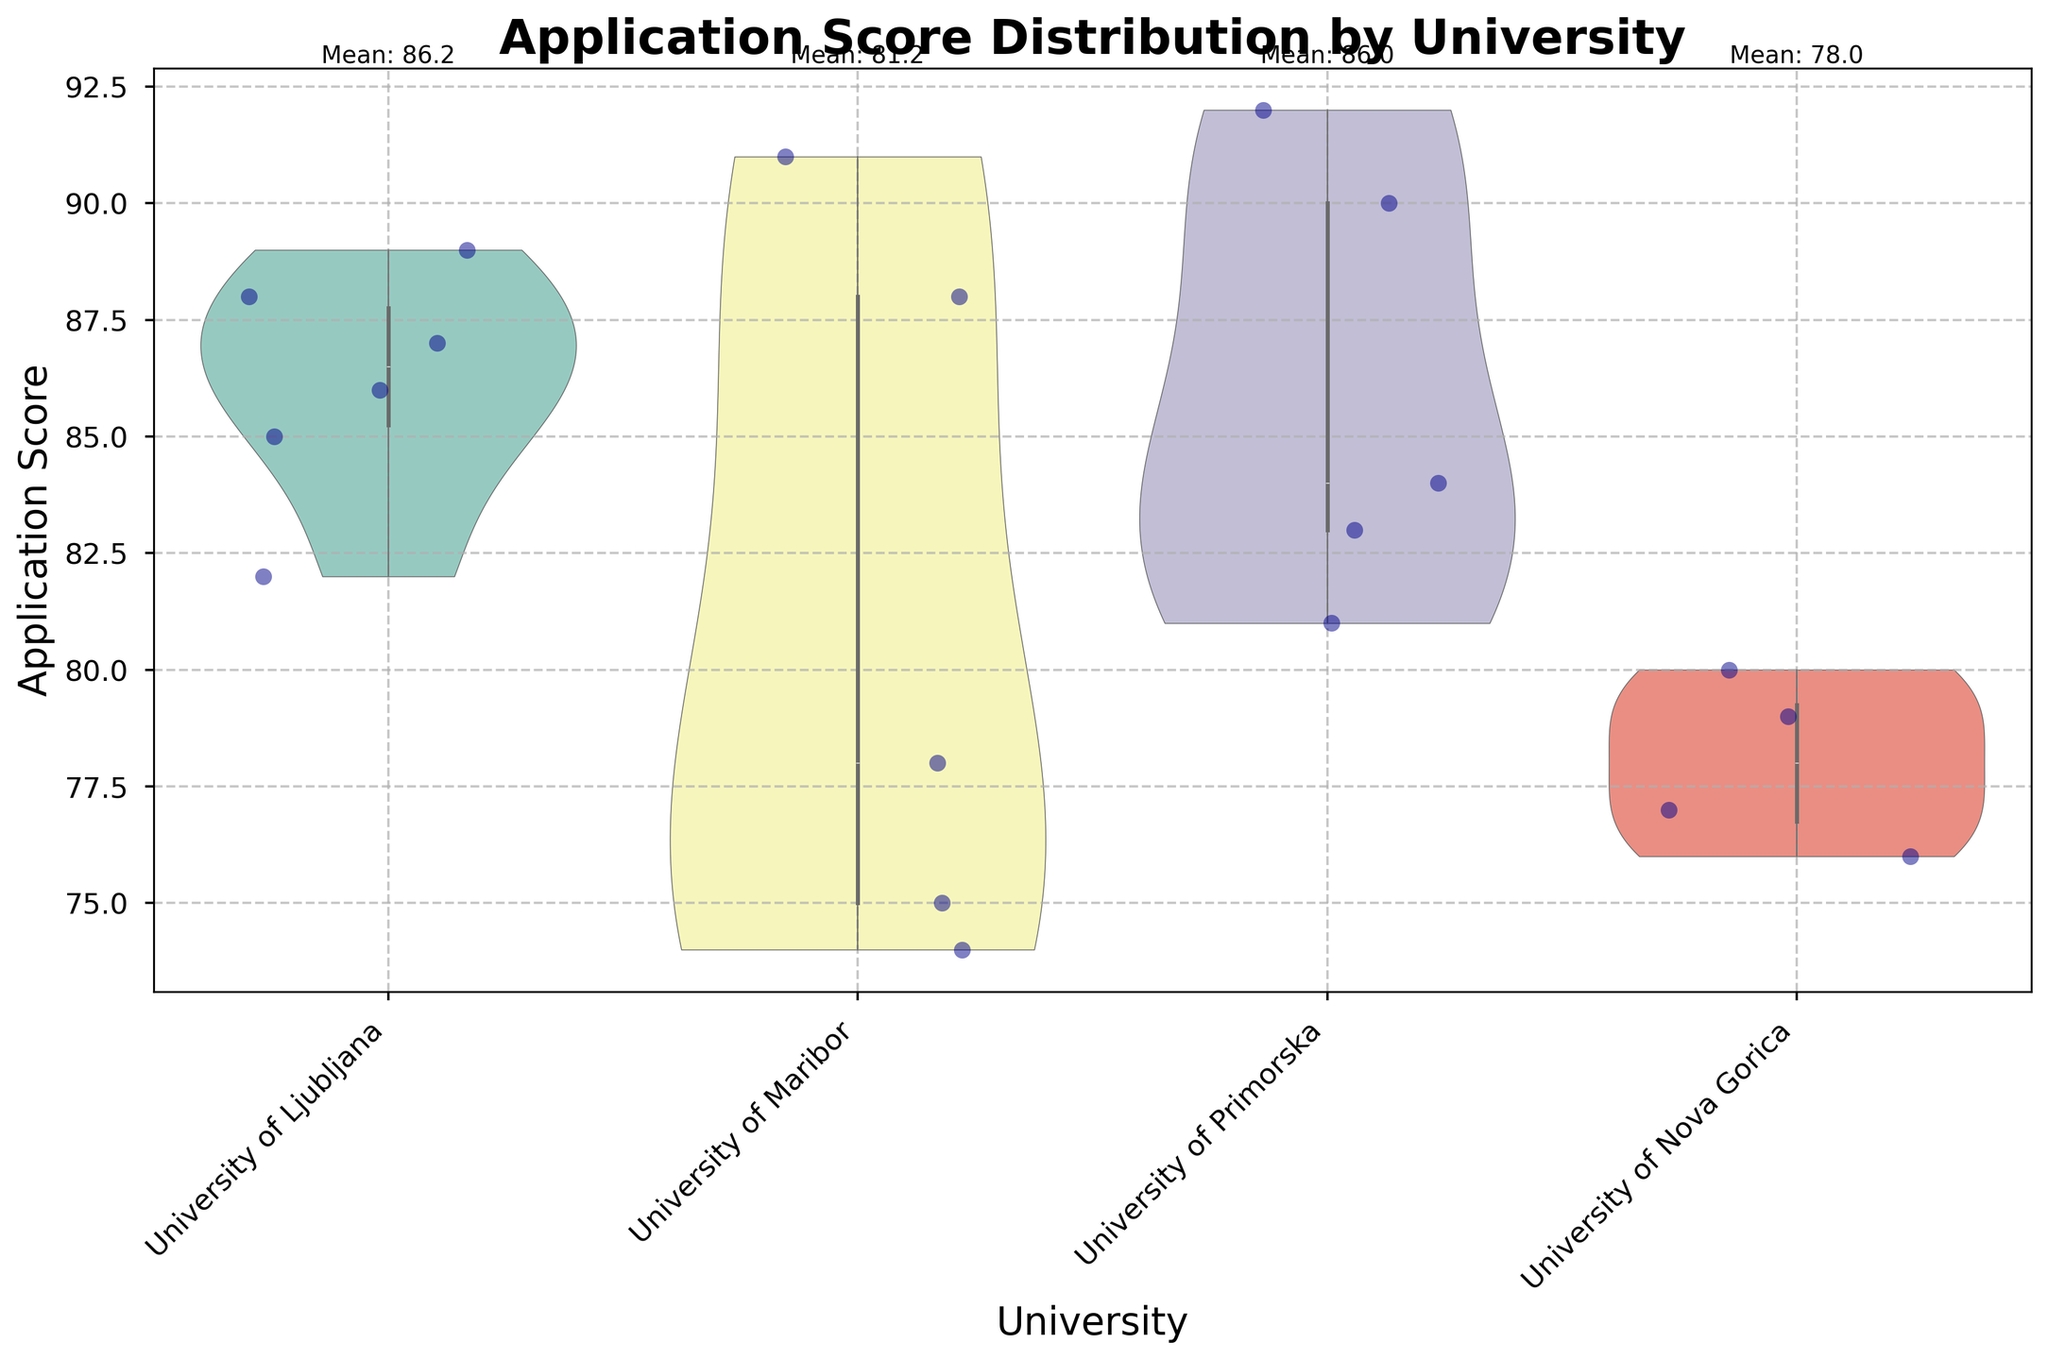What is the average Application Score for University of Ljubljana? The average Application Score is calculated by summing the scores of University of Ljubljana students and dividing by the number of students. There are 6 students with scores 85, 82, 88, 86, 87, 89. So, (85 + 82 + 88 + 86 + 87 + 89) / 6 = 85.67
Answer: 85.67 What is the highest Application Score recorded, and which university does it belong to? By examining the violin plots with jittered points, the highest score observed is 92, belonging to the University of Primorska.
Answer: 92, University of Primorska Which university has the widest range of Application Scores, and what is the range? By looking at the spread within the violin plots, University of Maribor has the widest range. The scores range from approximately 74 to 91, making the range 91 - 74 = 17.
Answer: University of Maribor, 17 What is the median Application Score for University of Nova Gorica? To find the median Application Score for University of Nova Gorica, list the scores (76, 80, 79, 77) and find the middle value, or average the two middle values if there are an even number of values. Here, the median is (77 + 79) / 2 = 78.
Answer: 78 How do the average Application Scores of University of Primorska and University of Maribor compare? Calculate the averages for both universities and compare. For Primorska: (90 + 92 + 83 + 81) / 4 = 86.5. For Maribor: (78 + 74 + 91 + 75 + 88) / 5 = 81.2. University of Primorska has a higher average score.
Answer: Primorska: 86.5, Maribor: 81.2 Which university has the most balanced distribution of Application Scores, and why? Look at the shape and spread of the violin plots. A more symmetrical plot with less spread indicates a balanced distribution. University of Ljubljana appears more balanced with less variation around the mean score.
Answer: University of Ljubljana What is the difference between the highest and lowest median Application Scores among the universities? Identify the median scores for each university. Ljubljana has a median close to 87, Maribor around 78, Primorska around 85, and Nova Gorica around 77. The difference is 87 - 77 = 10.
Answer: 10 What is the overall trend in Application Scores among the universities? Observing the vertical spread and density, application scores generally range between 75 and 92 across all universities with slight variation. No extreme outliers are seen, indicating a stable trend.
Answer: Stable trend with scores ranging 75-92 